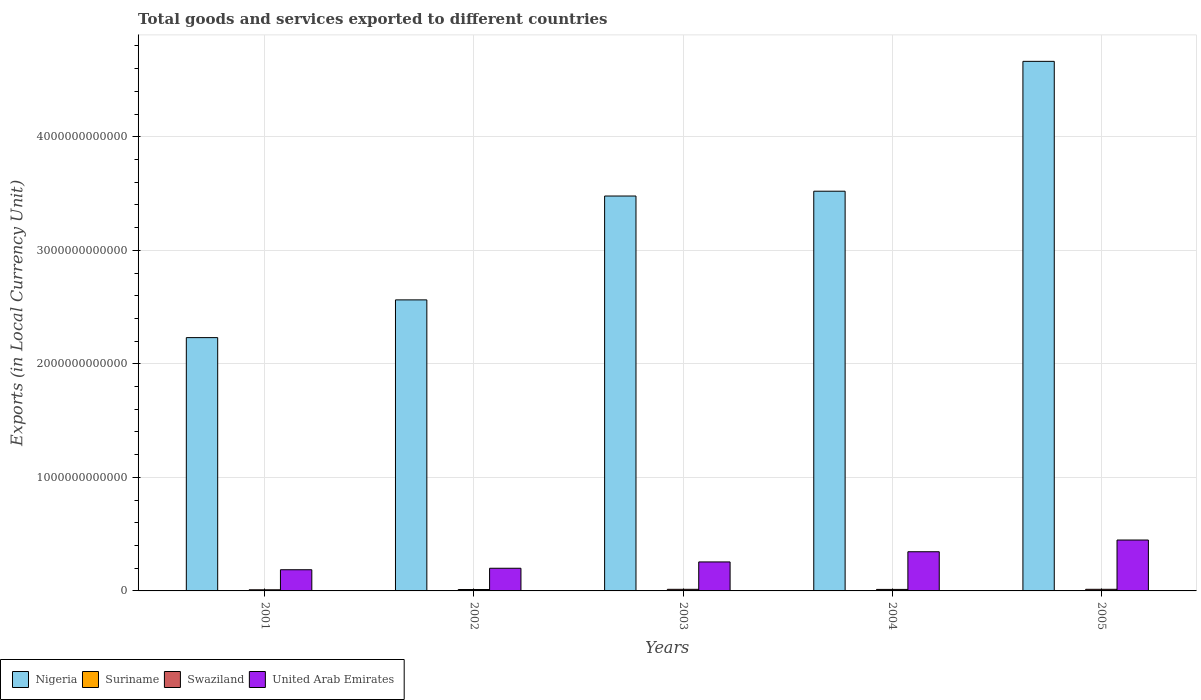How many different coloured bars are there?
Ensure brevity in your answer.  4. How many bars are there on the 3rd tick from the right?
Offer a very short reply. 4. What is the label of the 2nd group of bars from the left?
Your answer should be very brief. 2002. What is the Amount of goods and services exports in United Arab Emirates in 2002?
Ensure brevity in your answer.  2.00e+11. Across all years, what is the maximum Amount of goods and services exports in Nigeria?
Ensure brevity in your answer.  4.66e+12. Across all years, what is the minimum Amount of goods and services exports in United Arab Emirates?
Ensure brevity in your answer.  1.87e+11. In which year was the Amount of goods and services exports in Swaziland maximum?
Your answer should be very brief. 2005. In which year was the Amount of goods and services exports in Suriname minimum?
Give a very brief answer. 2001. What is the total Amount of goods and services exports in Swaziland in the graph?
Ensure brevity in your answer.  6.40e+1. What is the difference between the Amount of goods and services exports in Swaziland in 2002 and that in 2005?
Your answer should be very brief. -1.96e+09. What is the difference between the Amount of goods and services exports in United Arab Emirates in 2003 and the Amount of goods and services exports in Nigeria in 2005?
Your answer should be very brief. -4.41e+12. What is the average Amount of goods and services exports in Nigeria per year?
Provide a short and direct response. 3.29e+12. In the year 2003, what is the difference between the Amount of goods and services exports in Suriname and Amount of goods and services exports in United Arab Emirates?
Give a very brief answer. -2.55e+11. What is the ratio of the Amount of goods and services exports in Swaziland in 2001 to that in 2002?
Make the answer very short. 0.8. What is the difference between the highest and the second highest Amount of goods and services exports in Suriname?
Your answer should be compact. 4.31e+08. What is the difference between the highest and the lowest Amount of goods and services exports in Suriname?
Ensure brevity in your answer.  1.10e+09. In how many years, is the Amount of goods and services exports in Swaziland greater than the average Amount of goods and services exports in Swaziland taken over all years?
Make the answer very short. 3. What does the 2nd bar from the left in 2001 represents?
Make the answer very short. Suriname. What does the 4th bar from the right in 2003 represents?
Make the answer very short. Nigeria. Is it the case that in every year, the sum of the Amount of goods and services exports in Suriname and Amount of goods and services exports in Swaziland is greater than the Amount of goods and services exports in Nigeria?
Your answer should be very brief. No. Are all the bars in the graph horizontal?
Offer a terse response. No. How many years are there in the graph?
Offer a very short reply. 5. What is the difference between two consecutive major ticks on the Y-axis?
Give a very brief answer. 1.00e+12. Are the values on the major ticks of Y-axis written in scientific E-notation?
Your answer should be compact. No. Does the graph contain any zero values?
Give a very brief answer. No. Does the graph contain grids?
Provide a succinct answer. Yes. How are the legend labels stacked?
Offer a very short reply. Horizontal. What is the title of the graph?
Provide a succinct answer. Total goods and services exported to different countries. Does "Sweden" appear as one of the legend labels in the graph?
Give a very brief answer. No. What is the label or title of the X-axis?
Ensure brevity in your answer.  Years. What is the label or title of the Y-axis?
Keep it short and to the point. Exports (in Local Currency Unit). What is the Exports (in Local Currency Unit) in Nigeria in 2001?
Your answer should be very brief. 2.23e+12. What is the Exports (in Local Currency Unit) in Suriname in 2001?
Provide a succinct answer. 3.92e+08. What is the Exports (in Local Currency Unit) in Swaziland in 2001?
Your answer should be very brief. 9.93e+09. What is the Exports (in Local Currency Unit) of United Arab Emirates in 2001?
Make the answer very short. 1.87e+11. What is the Exports (in Local Currency Unit) of Nigeria in 2002?
Ensure brevity in your answer.  2.56e+12. What is the Exports (in Local Currency Unit) of Suriname in 2002?
Provide a short and direct response. 4.76e+08. What is the Exports (in Local Currency Unit) in Swaziland in 2002?
Offer a terse response. 1.24e+1. What is the Exports (in Local Currency Unit) of United Arab Emirates in 2002?
Give a very brief answer. 2.00e+11. What is the Exports (in Local Currency Unit) in Nigeria in 2003?
Your answer should be compact. 3.48e+12. What is the Exports (in Local Currency Unit) in Suriname in 2003?
Your answer should be compact. 6.53e+08. What is the Exports (in Local Currency Unit) in Swaziland in 2003?
Give a very brief answer. 1.42e+1. What is the Exports (in Local Currency Unit) of United Arab Emirates in 2003?
Provide a short and direct response. 2.55e+11. What is the Exports (in Local Currency Unit) of Nigeria in 2004?
Provide a succinct answer. 3.52e+12. What is the Exports (in Local Currency Unit) of Suriname in 2004?
Your answer should be very brief. 1.06e+09. What is the Exports (in Local Currency Unit) of Swaziland in 2004?
Your response must be concise. 1.33e+1. What is the Exports (in Local Currency Unit) in United Arab Emirates in 2004?
Provide a succinct answer. 3.45e+11. What is the Exports (in Local Currency Unit) in Nigeria in 2005?
Keep it short and to the point. 4.66e+12. What is the Exports (in Local Currency Unit) of Suriname in 2005?
Ensure brevity in your answer.  1.49e+09. What is the Exports (in Local Currency Unit) of Swaziland in 2005?
Offer a very short reply. 1.43e+1. What is the Exports (in Local Currency Unit) in United Arab Emirates in 2005?
Offer a terse response. 4.48e+11. Across all years, what is the maximum Exports (in Local Currency Unit) of Nigeria?
Provide a short and direct response. 4.66e+12. Across all years, what is the maximum Exports (in Local Currency Unit) of Suriname?
Keep it short and to the point. 1.49e+09. Across all years, what is the maximum Exports (in Local Currency Unit) in Swaziland?
Your answer should be compact. 1.43e+1. Across all years, what is the maximum Exports (in Local Currency Unit) in United Arab Emirates?
Ensure brevity in your answer.  4.48e+11. Across all years, what is the minimum Exports (in Local Currency Unit) in Nigeria?
Make the answer very short. 2.23e+12. Across all years, what is the minimum Exports (in Local Currency Unit) of Suriname?
Offer a terse response. 3.92e+08. Across all years, what is the minimum Exports (in Local Currency Unit) in Swaziland?
Your answer should be very brief. 9.93e+09. Across all years, what is the minimum Exports (in Local Currency Unit) in United Arab Emirates?
Give a very brief answer. 1.87e+11. What is the total Exports (in Local Currency Unit) of Nigeria in the graph?
Make the answer very short. 1.65e+13. What is the total Exports (in Local Currency Unit) of Suriname in the graph?
Your response must be concise. 4.07e+09. What is the total Exports (in Local Currency Unit) of Swaziland in the graph?
Your answer should be compact. 6.40e+1. What is the total Exports (in Local Currency Unit) in United Arab Emirates in the graph?
Your response must be concise. 1.43e+12. What is the difference between the Exports (in Local Currency Unit) of Nigeria in 2001 and that in 2002?
Make the answer very short. -3.32e+11. What is the difference between the Exports (in Local Currency Unit) in Suriname in 2001 and that in 2002?
Your response must be concise. -8.39e+07. What is the difference between the Exports (in Local Currency Unit) of Swaziland in 2001 and that in 2002?
Your answer should be compact. -2.43e+09. What is the difference between the Exports (in Local Currency Unit) of United Arab Emirates in 2001 and that in 2002?
Keep it short and to the point. -1.31e+1. What is the difference between the Exports (in Local Currency Unit) of Nigeria in 2001 and that in 2003?
Your answer should be compact. -1.25e+12. What is the difference between the Exports (in Local Currency Unit) in Suriname in 2001 and that in 2003?
Ensure brevity in your answer.  -2.61e+08. What is the difference between the Exports (in Local Currency Unit) of Swaziland in 2001 and that in 2003?
Ensure brevity in your answer.  -4.23e+09. What is the difference between the Exports (in Local Currency Unit) in United Arab Emirates in 2001 and that in 2003?
Give a very brief answer. -6.89e+1. What is the difference between the Exports (in Local Currency Unit) in Nigeria in 2001 and that in 2004?
Ensure brevity in your answer.  -1.29e+12. What is the difference between the Exports (in Local Currency Unit) in Suriname in 2001 and that in 2004?
Keep it short and to the point. -6.67e+08. What is the difference between the Exports (in Local Currency Unit) in Swaziland in 2001 and that in 2004?
Offer a very short reply. -3.35e+09. What is the difference between the Exports (in Local Currency Unit) in United Arab Emirates in 2001 and that in 2004?
Provide a succinct answer. -1.59e+11. What is the difference between the Exports (in Local Currency Unit) of Nigeria in 2001 and that in 2005?
Keep it short and to the point. -2.43e+12. What is the difference between the Exports (in Local Currency Unit) in Suriname in 2001 and that in 2005?
Your response must be concise. -1.10e+09. What is the difference between the Exports (in Local Currency Unit) in Swaziland in 2001 and that in 2005?
Your answer should be very brief. -4.38e+09. What is the difference between the Exports (in Local Currency Unit) of United Arab Emirates in 2001 and that in 2005?
Provide a succinct answer. -2.62e+11. What is the difference between the Exports (in Local Currency Unit) in Nigeria in 2002 and that in 2003?
Offer a very short reply. -9.15e+11. What is the difference between the Exports (in Local Currency Unit) in Suriname in 2002 and that in 2003?
Offer a terse response. -1.77e+08. What is the difference between the Exports (in Local Currency Unit) of Swaziland in 2002 and that in 2003?
Give a very brief answer. -1.81e+09. What is the difference between the Exports (in Local Currency Unit) in United Arab Emirates in 2002 and that in 2003?
Ensure brevity in your answer.  -5.57e+1. What is the difference between the Exports (in Local Currency Unit) in Nigeria in 2002 and that in 2004?
Your answer should be compact. -9.57e+11. What is the difference between the Exports (in Local Currency Unit) in Suriname in 2002 and that in 2004?
Provide a succinct answer. -5.83e+08. What is the difference between the Exports (in Local Currency Unit) of Swaziland in 2002 and that in 2004?
Offer a very short reply. -9.29e+08. What is the difference between the Exports (in Local Currency Unit) in United Arab Emirates in 2002 and that in 2004?
Make the answer very short. -1.45e+11. What is the difference between the Exports (in Local Currency Unit) in Nigeria in 2002 and that in 2005?
Make the answer very short. -2.10e+12. What is the difference between the Exports (in Local Currency Unit) of Suriname in 2002 and that in 2005?
Offer a very short reply. -1.01e+09. What is the difference between the Exports (in Local Currency Unit) of Swaziland in 2002 and that in 2005?
Your answer should be compact. -1.96e+09. What is the difference between the Exports (in Local Currency Unit) of United Arab Emirates in 2002 and that in 2005?
Offer a terse response. -2.49e+11. What is the difference between the Exports (in Local Currency Unit) of Nigeria in 2003 and that in 2004?
Make the answer very short. -4.23e+1. What is the difference between the Exports (in Local Currency Unit) of Suriname in 2003 and that in 2004?
Provide a short and direct response. -4.06e+08. What is the difference between the Exports (in Local Currency Unit) of Swaziland in 2003 and that in 2004?
Make the answer very short. 8.78e+08. What is the difference between the Exports (in Local Currency Unit) of United Arab Emirates in 2003 and that in 2004?
Make the answer very short. -8.97e+1. What is the difference between the Exports (in Local Currency Unit) of Nigeria in 2003 and that in 2005?
Ensure brevity in your answer.  -1.19e+12. What is the difference between the Exports (in Local Currency Unit) in Suriname in 2003 and that in 2005?
Your answer should be compact. -8.38e+08. What is the difference between the Exports (in Local Currency Unit) in Swaziland in 2003 and that in 2005?
Make the answer very short. -1.49e+08. What is the difference between the Exports (in Local Currency Unit) of United Arab Emirates in 2003 and that in 2005?
Your response must be concise. -1.93e+11. What is the difference between the Exports (in Local Currency Unit) in Nigeria in 2004 and that in 2005?
Make the answer very short. -1.14e+12. What is the difference between the Exports (in Local Currency Unit) in Suriname in 2004 and that in 2005?
Provide a short and direct response. -4.31e+08. What is the difference between the Exports (in Local Currency Unit) in Swaziland in 2004 and that in 2005?
Your answer should be very brief. -1.03e+09. What is the difference between the Exports (in Local Currency Unit) in United Arab Emirates in 2004 and that in 2005?
Ensure brevity in your answer.  -1.03e+11. What is the difference between the Exports (in Local Currency Unit) in Nigeria in 2001 and the Exports (in Local Currency Unit) in Suriname in 2002?
Offer a terse response. 2.23e+12. What is the difference between the Exports (in Local Currency Unit) in Nigeria in 2001 and the Exports (in Local Currency Unit) in Swaziland in 2002?
Your answer should be very brief. 2.22e+12. What is the difference between the Exports (in Local Currency Unit) of Nigeria in 2001 and the Exports (in Local Currency Unit) of United Arab Emirates in 2002?
Make the answer very short. 2.03e+12. What is the difference between the Exports (in Local Currency Unit) in Suriname in 2001 and the Exports (in Local Currency Unit) in Swaziland in 2002?
Keep it short and to the point. -1.20e+1. What is the difference between the Exports (in Local Currency Unit) in Suriname in 2001 and the Exports (in Local Currency Unit) in United Arab Emirates in 2002?
Offer a very short reply. -1.99e+11. What is the difference between the Exports (in Local Currency Unit) in Swaziland in 2001 and the Exports (in Local Currency Unit) in United Arab Emirates in 2002?
Make the answer very short. -1.90e+11. What is the difference between the Exports (in Local Currency Unit) in Nigeria in 2001 and the Exports (in Local Currency Unit) in Suriname in 2003?
Provide a succinct answer. 2.23e+12. What is the difference between the Exports (in Local Currency Unit) of Nigeria in 2001 and the Exports (in Local Currency Unit) of Swaziland in 2003?
Ensure brevity in your answer.  2.22e+12. What is the difference between the Exports (in Local Currency Unit) of Nigeria in 2001 and the Exports (in Local Currency Unit) of United Arab Emirates in 2003?
Offer a very short reply. 1.98e+12. What is the difference between the Exports (in Local Currency Unit) of Suriname in 2001 and the Exports (in Local Currency Unit) of Swaziland in 2003?
Ensure brevity in your answer.  -1.38e+1. What is the difference between the Exports (in Local Currency Unit) of Suriname in 2001 and the Exports (in Local Currency Unit) of United Arab Emirates in 2003?
Offer a terse response. -2.55e+11. What is the difference between the Exports (in Local Currency Unit) of Swaziland in 2001 and the Exports (in Local Currency Unit) of United Arab Emirates in 2003?
Keep it short and to the point. -2.45e+11. What is the difference between the Exports (in Local Currency Unit) of Nigeria in 2001 and the Exports (in Local Currency Unit) of Suriname in 2004?
Keep it short and to the point. 2.23e+12. What is the difference between the Exports (in Local Currency Unit) in Nigeria in 2001 and the Exports (in Local Currency Unit) in Swaziland in 2004?
Ensure brevity in your answer.  2.22e+12. What is the difference between the Exports (in Local Currency Unit) of Nigeria in 2001 and the Exports (in Local Currency Unit) of United Arab Emirates in 2004?
Provide a succinct answer. 1.89e+12. What is the difference between the Exports (in Local Currency Unit) in Suriname in 2001 and the Exports (in Local Currency Unit) in Swaziland in 2004?
Your answer should be very brief. -1.29e+1. What is the difference between the Exports (in Local Currency Unit) of Suriname in 2001 and the Exports (in Local Currency Unit) of United Arab Emirates in 2004?
Provide a succinct answer. -3.45e+11. What is the difference between the Exports (in Local Currency Unit) in Swaziland in 2001 and the Exports (in Local Currency Unit) in United Arab Emirates in 2004?
Give a very brief answer. -3.35e+11. What is the difference between the Exports (in Local Currency Unit) in Nigeria in 2001 and the Exports (in Local Currency Unit) in Suriname in 2005?
Offer a very short reply. 2.23e+12. What is the difference between the Exports (in Local Currency Unit) in Nigeria in 2001 and the Exports (in Local Currency Unit) in Swaziland in 2005?
Offer a very short reply. 2.22e+12. What is the difference between the Exports (in Local Currency Unit) in Nigeria in 2001 and the Exports (in Local Currency Unit) in United Arab Emirates in 2005?
Offer a very short reply. 1.78e+12. What is the difference between the Exports (in Local Currency Unit) in Suriname in 2001 and the Exports (in Local Currency Unit) in Swaziland in 2005?
Your response must be concise. -1.39e+1. What is the difference between the Exports (in Local Currency Unit) in Suriname in 2001 and the Exports (in Local Currency Unit) in United Arab Emirates in 2005?
Provide a short and direct response. -4.48e+11. What is the difference between the Exports (in Local Currency Unit) of Swaziland in 2001 and the Exports (in Local Currency Unit) of United Arab Emirates in 2005?
Your answer should be compact. -4.38e+11. What is the difference between the Exports (in Local Currency Unit) of Nigeria in 2002 and the Exports (in Local Currency Unit) of Suriname in 2003?
Provide a succinct answer. 2.56e+12. What is the difference between the Exports (in Local Currency Unit) in Nigeria in 2002 and the Exports (in Local Currency Unit) in Swaziland in 2003?
Offer a terse response. 2.55e+12. What is the difference between the Exports (in Local Currency Unit) in Nigeria in 2002 and the Exports (in Local Currency Unit) in United Arab Emirates in 2003?
Provide a succinct answer. 2.31e+12. What is the difference between the Exports (in Local Currency Unit) of Suriname in 2002 and the Exports (in Local Currency Unit) of Swaziland in 2003?
Provide a succinct answer. -1.37e+1. What is the difference between the Exports (in Local Currency Unit) in Suriname in 2002 and the Exports (in Local Currency Unit) in United Arab Emirates in 2003?
Keep it short and to the point. -2.55e+11. What is the difference between the Exports (in Local Currency Unit) of Swaziland in 2002 and the Exports (in Local Currency Unit) of United Arab Emirates in 2003?
Provide a short and direct response. -2.43e+11. What is the difference between the Exports (in Local Currency Unit) in Nigeria in 2002 and the Exports (in Local Currency Unit) in Suriname in 2004?
Provide a short and direct response. 2.56e+12. What is the difference between the Exports (in Local Currency Unit) of Nigeria in 2002 and the Exports (in Local Currency Unit) of Swaziland in 2004?
Your response must be concise. 2.55e+12. What is the difference between the Exports (in Local Currency Unit) in Nigeria in 2002 and the Exports (in Local Currency Unit) in United Arab Emirates in 2004?
Provide a short and direct response. 2.22e+12. What is the difference between the Exports (in Local Currency Unit) of Suriname in 2002 and the Exports (in Local Currency Unit) of Swaziland in 2004?
Keep it short and to the point. -1.28e+1. What is the difference between the Exports (in Local Currency Unit) in Suriname in 2002 and the Exports (in Local Currency Unit) in United Arab Emirates in 2004?
Your answer should be compact. -3.45e+11. What is the difference between the Exports (in Local Currency Unit) of Swaziland in 2002 and the Exports (in Local Currency Unit) of United Arab Emirates in 2004?
Ensure brevity in your answer.  -3.33e+11. What is the difference between the Exports (in Local Currency Unit) of Nigeria in 2002 and the Exports (in Local Currency Unit) of Suriname in 2005?
Your answer should be very brief. 2.56e+12. What is the difference between the Exports (in Local Currency Unit) in Nigeria in 2002 and the Exports (in Local Currency Unit) in Swaziland in 2005?
Offer a very short reply. 2.55e+12. What is the difference between the Exports (in Local Currency Unit) in Nigeria in 2002 and the Exports (in Local Currency Unit) in United Arab Emirates in 2005?
Offer a very short reply. 2.12e+12. What is the difference between the Exports (in Local Currency Unit) of Suriname in 2002 and the Exports (in Local Currency Unit) of Swaziland in 2005?
Keep it short and to the point. -1.38e+1. What is the difference between the Exports (in Local Currency Unit) of Suriname in 2002 and the Exports (in Local Currency Unit) of United Arab Emirates in 2005?
Your answer should be very brief. -4.48e+11. What is the difference between the Exports (in Local Currency Unit) in Swaziland in 2002 and the Exports (in Local Currency Unit) in United Arab Emirates in 2005?
Provide a short and direct response. -4.36e+11. What is the difference between the Exports (in Local Currency Unit) in Nigeria in 2003 and the Exports (in Local Currency Unit) in Suriname in 2004?
Give a very brief answer. 3.48e+12. What is the difference between the Exports (in Local Currency Unit) in Nigeria in 2003 and the Exports (in Local Currency Unit) in Swaziland in 2004?
Provide a short and direct response. 3.47e+12. What is the difference between the Exports (in Local Currency Unit) of Nigeria in 2003 and the Exports (in Local Currency Unit) of United Arab Emirates in 2004?
Offer a terse response. 3.13e+12. What is the difference between the Exports (in Local Currency Unit) of Suriname in 2003 and the Exports (in Local Currency Unit) of Swaziland in 2004?
Provide a short and direct response. -1.26e+1. What is the difference between the Exports (in Local Currency Unit) of Suriname in 2003 and the Exports (in Local Currency Unit) of United Arab Emirates in 2004?
Offer a very short reply. -3.44e+11. What is the difference between the Exports (in Local Currency Unit) in Swaziland in 2003 and the Exports (in Local Currency Unit) in United Arab Emirates in 2004?
Provide a short and direct response. -3.31e+11. What is the difference between the Exports (in Local Currency Unit) in Nigeria in 2003 and the Exports (in Local Currency Unit) in Suriname in 2005?
Give a very brief answer. 3.48e+12. What is the difference between the Exports (in Local Currency Unit) in Nigeria in 2003 and the Exports (in Local Currency Unit) in Swaziland in 2005?
Keep it short and to the point. 3.46e+12. What is the difference between the Exports (in Local Currency Unit) of Nigeria in 2003 and the Exports (in Local Currency Unit) of United Arab Emirates in 2005?
Make the answer very short. 3.03e+12. What is the difference between the Exports (in Local Currency Unit) of Suriname in 2003 and the Exports (in Local Currency Unit) of Swaziland in 2005?
Your answer should be very brief. -1.37e+1. What is the difference between the Exports (in Local Currency Unit) in Suriname in 2003 and the Exports (in Local Currency Unit) in United Arab Emirates in 2005?
Offer a very short reply. -4.48e+11. What is the difference between the Exports (in Local Currency Unit) in Swaziland in 2003 and the Exports (in Local Currency Unit) in United Arab Emirates in 2005?
Give a very brief answer. -4.34e+11. What is the difference between the Exports (in Local Currency Unit) of Nigeria in 2004 and the Exports (in Local Currency Unit) of Suriname in 2005?
Give a very brief answer. 3.52e+12. What is the difference between the Exports (in Local Currency Unit) in Nigeria in 2004 and the Exports (in Local Currency Unit) in Swaziland in 2005?
Provide a short and direct response. 3.51e+12. What is the difference between the Exports (in Local Currency Unit) of Nigeria in 2004 and the Exports (in Local Currency Unit) of United Arab Emirates in 2005?
Your answer should be very brief. 3.07e+12. What is the difference between the Exports (in Local Currency Unit) of Suriname in 2004 and the Exports (in Local Currency Unit) of Swaziland in 2005?
Provide a succinct answer. -1.32e+1. What is the difference between the Exports (in Local Currency Unit) of Suriname in 2004 and the Exports (in Local Currency Unit) of United Arab Emirates in 2005?
Give a very brief answer. -4.47e+11. What is the difference between the Exports (in Local Currency Unit) of Swaziland in 2004 and the Exports (in Local Currency Unit) of United Arab Emirates in 2005?
Offer a terse response. -4.35e+11. What is the average Exports (in Local Currency Unit) in Nigeria per year?
Your response must be concise. 3.29e+12. What is the average Exports (in Local Currency Unit) in Suriname per year?
Offer a very short reply. 8.14e+08. What is the average Exports (in Local Currency Unit) in Swaziland per year?
Provide a succinct answer. 1.28e+1. What is the average Exports (in Local Currency Unit) in United Arab Emirates per year?
Keep it short and to the point. 2.87e+11. In the year 2001, what is the difference between the Exports (in Local Currency Unit) of Nigeria and Exports (in Local Currency Unit) of Suriname?
Keep it short and to the point. 2.23e+12. In the year 2001, what is the difference between the Exports (in Local Currency Unit) of Nigeria and Exports (in Local Currency Unit) of Swaziland?
Ensure brevity in your answer.  2.22e+12. In the year 2001, what is the difference between the Exports (in Local Currency Unit) of Nigeria and Exports (in Local Currency Unit) of United Arab Emirates?
Ensure brevity in your answer.  2.04e+12. In the year 2001, what is the difference between the Exports (in Local Currency Unit) in Suriname and Exports (in Local Currency Unit) in Swaziland?
Ensure brevity in your answer.  -9.53e+09. In the year 2001, what is the difference between the Exports (in Local Currency Unit) in Suriname and Exports (in Local Currency Unit) in United Arab Emirates?
Provide a succinct answer. -1.86e+11. In the year 2001, what is the difference between the Exports (in Local Currency Unit) of Swaziland and Exports (in Local Currency Unit) of United Arab Emirates?
Give a very brief answer. -1.77e+11. In the year 2002, what is the difference between the Exports (in Local Currency Unit) of Nigeria and Exports (in Local Currency Unit) of Suriname?
Your answer should be very brief. 2.56e+12. In the year 2002, what is the difference between the Exports (in Local Currency Unit) in Nigeria and Exports (in Local Currency Unit) in Swaziland?
Make the answer very short. 2.55e+12. In the year 2002, what is the difference between the Exports (in Local Currency Unit) of Nigeria and Exports (in Local Currency Unit) of United Arab Emirates?
Offer a very short reply. 2.36e+12. In the year 2002, what is the difference between the Exports (in Local Currency Unit) in Suriname and Exports (in Local Currency Unit) in Swaziland?
Your answer should be compact. -1.19e+1. In the year 2002, what is the difference between the Exports (in Local Currency Unit) of Suriname and Exports (in Local Currency Unit) of United Arab Emirates?
Give a very brief answer. -1.99e+11. In the year 2002, what is the difference between the Exports (in Local Currency Unit) in Swaziland and Exports (in Local Currency Unit) in United Arab Emirates?
Your answer should be compact. -1.87e+11. In the year 2003, what is the difference between the Exports (in Local Currency Unit) in Nigeria and Exports (in Local Currency Unit) in Suriname?
Provide a short and direct response. 3.48e+12. In the year 2003, what is the difference between the Exports (in Local Currency Unit) of Nigeria and Exports (in Local Currency Unit) of Swaziland?
Ensure brevity in your answer.  3.46e+12. In the year 2003, what is the difference between the Exports (in Local Currency Unit) in Nigeria and Exports (in Local Currency Unit) in United Arab Emirates?
Keep it short and to the point. 3.22e+12. In the year 2003, what is the difference between the Exports (in Local Currency Unit) of Suriname and Exports (in Local Currency Unit) of Swaziland?
Give a very brief answer. -1.35e+1. In the year 2003, what is the difference between the Exports (in Local Currency Unit) of Suriname and Exports (in Local Currency Unit) of United Arab Emirates?
Make the answer very short. -2.55e+11. In the year 2003, what is the difference between the Exports (in Local Currency Unit) of Swaziland and Exports (in Local Currency Unit) of United Arab Emirates?
Give a very brief answer. -2.41e+11. In the year 2004, what is the difference between the Exports (in Local Currency Unit) in Nigeria and Exports (in Local Currency Unit) in Suriname?
Offer a terse response. 3.52e+12. In the year 2004, what is the difference between the Exports (in Local Currency Unit) in Nigeria and Exports (in Local Currency Unit) in Swaziland?
Your answer should be compact. 3.51e+12. In the year 2004, what is the difference between the Exports (in Local Currency Unit) in Nigeria and Exports (in Local Currency Unit) in United Arab Emirates?
Provide a succinct answer. 3.18e+12. In the year 2004, what is the difference between the Exports (in Local Currency Unit) of Suriname and Exports (in Local Currency Unit) of Swaziland?
Ensure brevity in your answer.  -1.22e+1. In the year 2004, what is the difference between the Exports (in Local Currency Unit) of Suriname and Exports (in Local Currency Unit) of United Arab Emirates?
Your answer should be compact. -3.44e+11. In the year 2004, what is the difference between the Exports (in Local Currency Unit) in Swaziland and Exports (in Local Currency Unit) in United Arab Emirates?
Make the answer very short. -3.32e+11. In the year 2005, what is the difference between the Exports (in Local Currency Unit) in Nigeria and Exports (in Local Currency Unit) in Suriname?
Make the answer very short. 4.66e+12. In the year 2005, what is the difference between the Exports (in Local Currency Unit) of Nigeria and Exports (in Local Currency Unit) of Swaziland?
Provide a short and direct response. 4.65e+12. In the year 2005, what is the difference between the Exports (in Local Currency Unit) in Nigeria and Exports (in Local Currency Unit) in United Arab Emirates?
Ensure brevity in your answer.  4.22e+12. In the year 2005, what is the difference between the Exports (in Local Currency Unit) in Suriname and Exports (in Local Currency Unit) in Swaziland?
Ensure brevity in your answer.  -1.28e+1. In the year 2005, what is the difference between the Exports (in Local Currency Unit) in Suriname and Exports (in Local Currency Unit) in United Arab Emirates?
Keep it short and to the point. -4.47e+11. In the year 2005, what is the difference between the Exports (in Local Currency Unit) of Swaziland and Exports (in Local Currency Unit) of United Arab Emirates?
Provide a short and direct response. -4.34e+11. What is the ratio of the Exports (in Local Currency Unit) in Nigeria in 2001 to that in 2002?
Provide a short and direct response. 0.87. What is the ratio of the Exports (in Local Currency Unit) of Suriname in 2001 to that in 2002?
Provide a short and direct response. 0.82. What is the ratio of the Exports (in Local Currency Unit) in Swaziland in 2001 to that in 2002?
Provide a succinct answer. 0.8. What is the ratio of the Exports (in Local Currency Unit) in United Arab Emirates in 2001 to that in 2002?
Ensure brevity in your answer.  0.93. What is the ratio of the Exports (in Local Currency Unit) in Nigeria in 2001 to that in 2003?
Your answer should be compact. 0.64. What is the ratio of the Exports (in Local Currency Unit) in Suriname in 2001 to that in 2003?
Your answer should be compact. 0.6. What is the ratio of the Exports (in Local Currency Unit) in Swaziland in 2001 to that in 2003?
Your answer should be very brief. 0.7. What is the ratio of the Exports (in Local Currency Unit) in United Arab Emirates in 2001 to that in 2003?
Your answer should be compact. 0.73. What is the ratio of the Exports (in Local Currency Unit) of Nigeria in 2001 to that in 2004?
Ensure brevity in your answer.  0.63. What is the ratio of the Exports (in Local Currency Unit) of Suriname in 2001 to that in 2004?
Offer a very short reply. 0.37. What is the ratio of the Exports (in Local Currency Unit) in Swaziland in 2001 to that in 2004?
Offer a very short reply. 0.75. What is the ratio of the Exports (in Local Currency Unit) of United Arab Emirates in 2001 to that in 2004?
Offer a very short reply. 0.54. What is the ratio of the Exports (in Local Currency Unit) of Nigeria in 2001 to that in 2005?
Give a very brief answer. 0.48. What is the ratio of the Exports (in Local Currency Unit) in Suriname in 2001 to that in 2005?
Offer a terse response. 0.26. What is the ratio of the Exports (in Local Currency Unit) in Swaziland in 2001 to that in 2005?
Give a very brief answer. 0.69. What is the ratio of the Exports (in Local Currency Unit) of United Arab Emirates in 2001 to that in 2005?
Provide a succinct answer. 0.42. What is the ratio of the Exports (in Local Currency Unit) in Nigeria in 2002 to that in 2003?
Keep it short and to the point. 0.74. What is the ratio of the Exports (in Local Currency Unit) of Suriname in 2002 to that in 2003?
Offer a terse response. 0.73. What is the ratio of the Exports (in Local Currency Unit) of Swaziland in 2002 to that in 2003?
Provide a short and direct response. 0.87. What is the ratio of the Exports (in Local Currency Unit) of United Arab Emirates in 2002 to that in 2003?
Make the answer very short. 0.78. What is the ratio of the Exports (in Local Currency Unit) of Nigeria in 2002 to that in 2004?
Your response must be concise. 0.73. What is the ratio of the Exports (in Local Currency Unit) in Suriname in 2002 to that in 2004?
Your answer should be compact. 0.45. What is the ratio of the Exports (in Local Currency Unit) of United Arab Emirates in 2002 to that in 2004?
Your answer should be compact. 0.58. What is the ratio of the Exports (in Local Currency Unit) in Nigeria in 2002 to that in 2005?
Provide a succinct answer. 0.55. What is the ratio of the Exports (in Local Currency Unit) of Suriname in 2002 to that in 2005?
Offer a very short reply. 0.32. What is the ratio of the Exports (in Local Currency Unit) of Swaziland in 2002 to that in 2005?
Offer a very short reply. 0.86. What is the ratio of the Exports (in Local Currency Unit) in United Arab Emirates in 2002 to that in 2005?
Offer a terse response. 0.45. What is the ratio of the Exports (in Local Currency Unit) of Suriname in 2003 to that in 2004?
Ensure brevity in your answer.  0.62. What is the ratio of the Exports (in Local Currency Unit) in Swaziland in 2003 to that in 2004?
Ensure brevity in your answer.  1.07. What is the ratio of the Exports (in Local Currency Unit) of United Arab Emirates in 2003 to that in 2004?
Provide a short and direct response. 0.74. What is the ratio of the Exports (in Local Currency Unit) in Nigeria in 2003 to that in 2005?
Provide a succinct answer. 0.75. What is the ratio of the Exports (in Local Currency Unit) in Suriname in 2003 to that in 2005?
Make the answer very short. 0.44. What is the ratio of the Exports (in Local Currency Unit) of Swaziland in 2003 to that in 2005?
Give a very brief answer. 0.99. What is the ratio of the Exports (in Local Currency Unit) of United Arab Emirates in 2003 to that in 2005?
Your response must be concise. 0.57. What is the ratio of the Exports (in Local Currency Unit) of Nigeria in 2004 to that in 2005?
Offer a terse response. 0.75. What is the ratio of the Exports (in Local Currency Unit) in Suriname in 2004 to that in 2005?
Offer a very short reply. 0.71. What is the ratio of the Exports (in Local Currency Unit) in Swaziland in 2004 to that in 2005?
Your response must be concise. 0.93. What is the ratio of the Exports (in Local Currency Unit) of United Arab Emirates in 2004 to that in 2005?
Ensure brevity in your answer.  0.77. What is the difference between the highest and the second highest Exports (in Local Currency Unit) in Nigeria?
Provide a succinct answer. 1.14e+12. What is the difference between the highest and the second highest Exports (in Local Currency Unit) in Suriname?
Give a very brief answer. 4.31e+08. What is the difference between the highest and the second highest Exports (in Local Currency Unit) of Swaziland?
Offer a very short reply. 1.49e+08. What is the difference between the highest and the second highest Exports (in Local Currency Unit) in United Arab Emirates?
Ensure brevity in your answer.  1.03e+11. What is the difference between the highest and the lowest Exports (in Local Currency Unit) of Nigeria?
Offer a very short reply. 2.43e+12. What is the difference between the highest and the lowest Exports (in Local Currency Unit) of Suriname?
Your response must be concise. 1.10e+09. What is the difference between the highest and the lowest Exports (in Local Currency Unit) in Swaziland?
Your response must be concise. 4.38e+09. What is the difference between the highest and the lowest Exports (in Local Currency Unit) in United Arab Emirates?
Keep it short and to the point. 2.62e+11. 